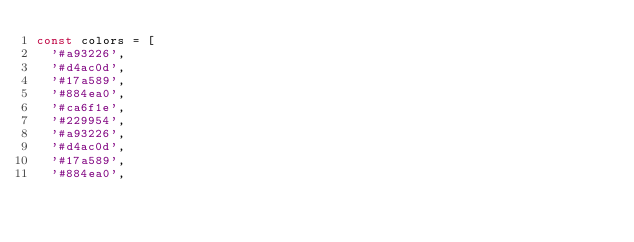Convert code to text. <code><loc_0><loc_0><loc_500><loc_500><_JavaScript_>const colors = [
  '#a93226',
  '#d4ac0d',
  '#17a589',
  '#884ea0',
  '#ca6f1e',
  '#229954',
  '#a93226',
  '#d4ac0d',
  '#17a589',
  '#884ea0',</code> 